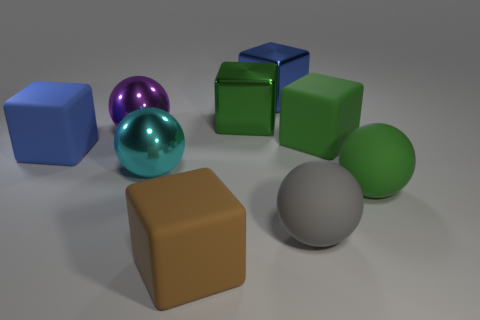Describe the texture and apparent material of the objects in the image. The objects in the image appear to have smooth textures with various materials indicated by their finish: the green and purple spheres look metallic given their reflective surfaces, while the other objects appear matte, suggesting non-metallic materials such as plastic or painted surfaces. 